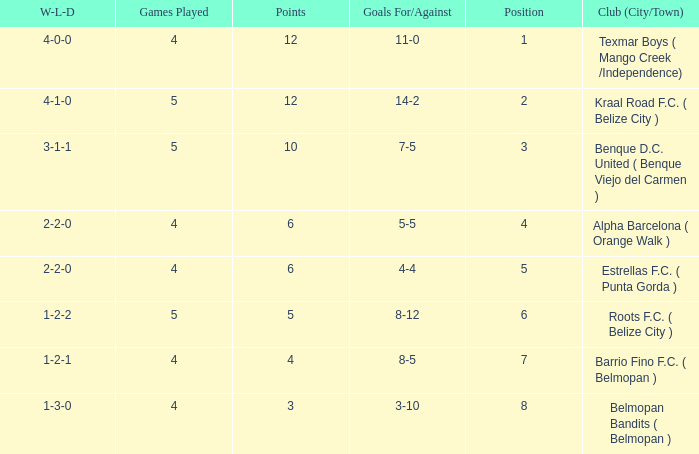Would you mind parsing the complete table? {'header': ['W-L-D', 'Games Played', 'Points', 'Goals For/Against', 'Position', 'Club (City/Town)'], 'rows': [['4-0-0', '4', '12', '11-0', '1', 'Texmar Boys ( Mango Creek /Independence)'], ['4-1-0', '5', '12', '14-2', '2', 'Kraal Road F.C. ( Belize City )'], ['3-1-1', '5', '10', '7-5', '3', 'Benque D.C. United ( Benque Viejo del Carmen )'], ['2-2-0', '4', '6', '5-5', '4', 'Alpha Barcelona ( Orange Walk )'], ['2-2-0', '4', '6', '4-4', '5', 'Estrellas F.C. ( Punta Gorda )'], ['1-2-2', '5', '5', '8-12', '6', 'Roots F.C. ( Belize City )'], ['1-2-1', '4', '4', '8-5', '7', 'Barrio Fino F.C. ( Belmopan )'], ['1-3-0', '4', '3', '3-10', '8', 'Belmopan Bandits ( Belmopan )']]} What's the w-l-d with position being 1 4-0-0. 